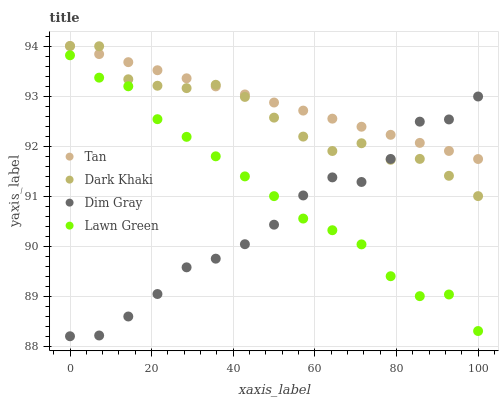Does Dim Gray have the minimum area under the curve?
Answer yes or no. Yes. Does Tan have the maximum area under the curve?
Answer yes or no. Yes. Does Lawn Green have the minimum area under the curve?
Answer yes or no. No. Does Lawn Green have the maximum area under the curve?
Answer yes or no. No. Is Tan the smoothest?
Answer yes or no. Yes. Is Dim Gray the roughest?
Answer yes or no. Yes. Is Lawn Green the smoothest?
Answer yes or no. No. Is Lawn Green the roughest?
Answer yes or no. No. Does Dim Gray have the lowest value?
Answer yes or no. Yes. Does Lawn Green have the lowest value?
Answer yes or no. No. Does Tan have the highest value?
Answer yes or no. Yes. Does Lawn Green have the highest value?
Answer yes or no. No. Is Lawn Green less than Tan?
Answer yes or no. Yes. Is Tan greater than Lawn Green?
Answer yes or no. Yes. Does Dim Gray intersect Dark Khaki?
Answer yes or no. Yes. Is Dim Gray less than Dark Khaki?
Answer yes or no. No. Is Dim Gray greater than Dark Khaki?
Answer yes or no. No. Does Lawn Green intersect Tan?
Answer yes or no. No. 